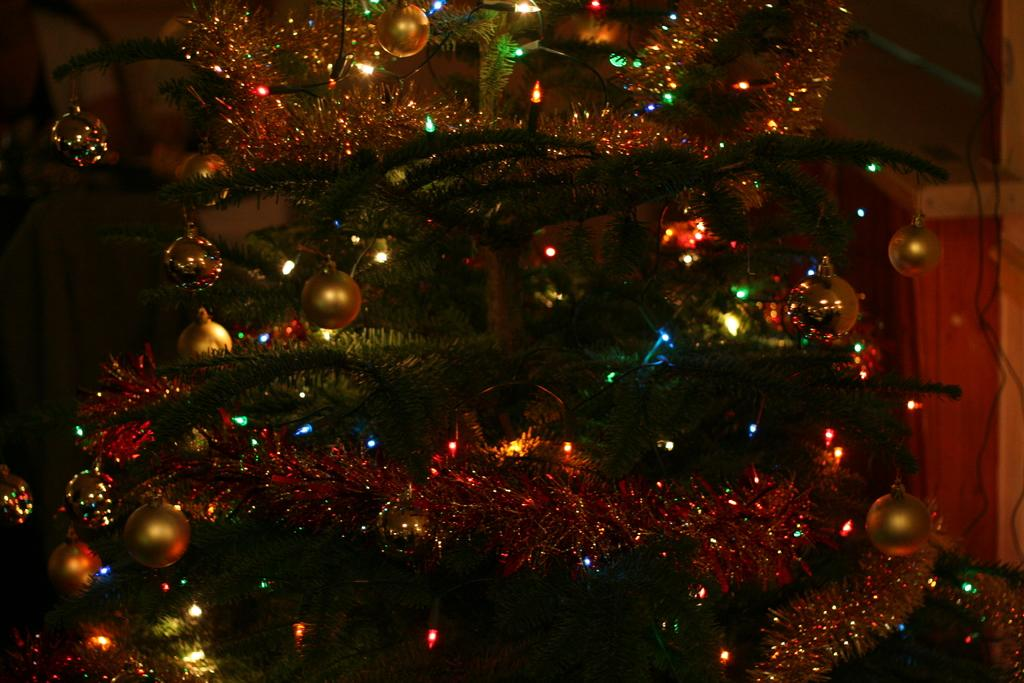What is present in the image that resembles a plant? There is a tree in the image. How is the tree in the image decorated? The tree is decorated with balls and lights. What type of invention can be seen in the image? There is no invention present in the image; it features a decorated tree. How many wrens are perched on the branches of the tree in the image? There are no wrens present in the image. 